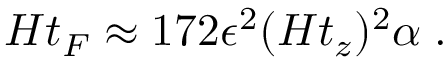Convert formula to latex. <formula><loc_0><loc_0><loc_500><loc_500>H t _ { F } \approx 1 7 2 \epsilon ^ { 2 } ( H t _ { z } ) ^ { 2 } \alpha \, .</formula> 